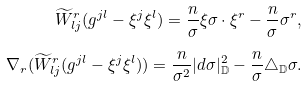Convert formula to latex. <formula><loc_0><loc_0><loc_500><loc_500>\widetilde { W } _ { l j } ^ { r } ( g ^ { j l } - \xi ^ { j } \xi ^ { l } ) = \frac { n } { \sigma } \xi \sigma \cdot \xi ^ { r } - \frac { n } { \sigma } \sigma ^ { r } , \\ \nabla _ { r } ( \widetilde { W } _ { l j } ^ { r } ( g ^ { j l } - \xi ^ { j } \xi ^ { l } ) ) = \frac { n } { \sigma ^ { 2 } } | d \sigma | _ { \mathbb { D } } ^ { 2 } - \frac { n } { \sigma } \triangle _ { \mathbb { D } } \sigma .</formula> 